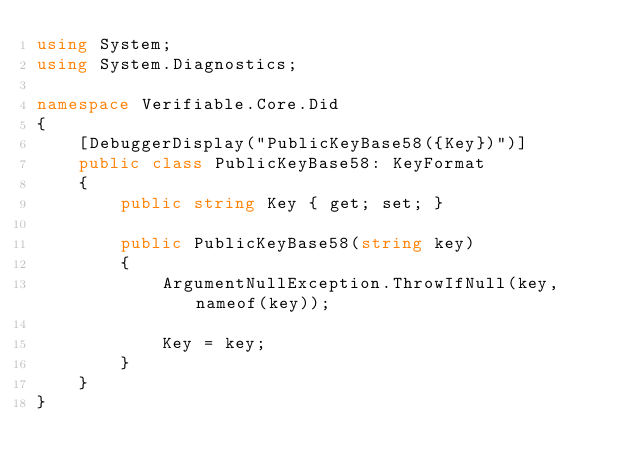<code> <loc_0><loc_0><loc_500><loc_500><_C#_>using System;
using System.Diagnostics;

namespace Verifiable.Core.Did
{
    [DebuggerDisplay("PublicKeyBase58({Key})")]
    public class PublicKeyBase58: KeyFormat
    {
        public string Key { get; set; }

        public PublicKeyBase58(string key)
        {
            ArgumentNullException.ThrowIfNull(key, nameof(key));

            Key = key;
        }
    }
}
</code> 